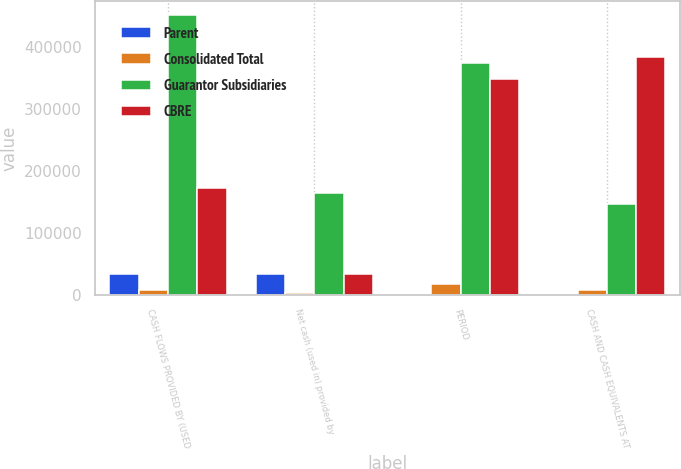Convert chart to OTSL. <chart><loc_0><loc_0><loc_500><loc_500><stacked_bar_chart><ecel><fcel>CASH FLOWS PROVIDED BY (USED<fcel>Net cash (used in) provided by<fcel>PERIOD<fcel>CASH AND CASH EQUIVALENTS AT<nl><fcel>Parent<fcel>33959<fcel>33959<fcel>5<fcel>5<nl><fcel>Consolidated Total<fcel>7477<fcel>2306<fcel>18262<fcel>8479<nl><fcel>Guarantor Subsidiaries<fcel>452304<fcel>163956<fcel>374103<fcel>147410<nl><fcel>CBRE<fcel>173111<fcel>33959<fcel>348514<fcel>384509<nl></chart> 